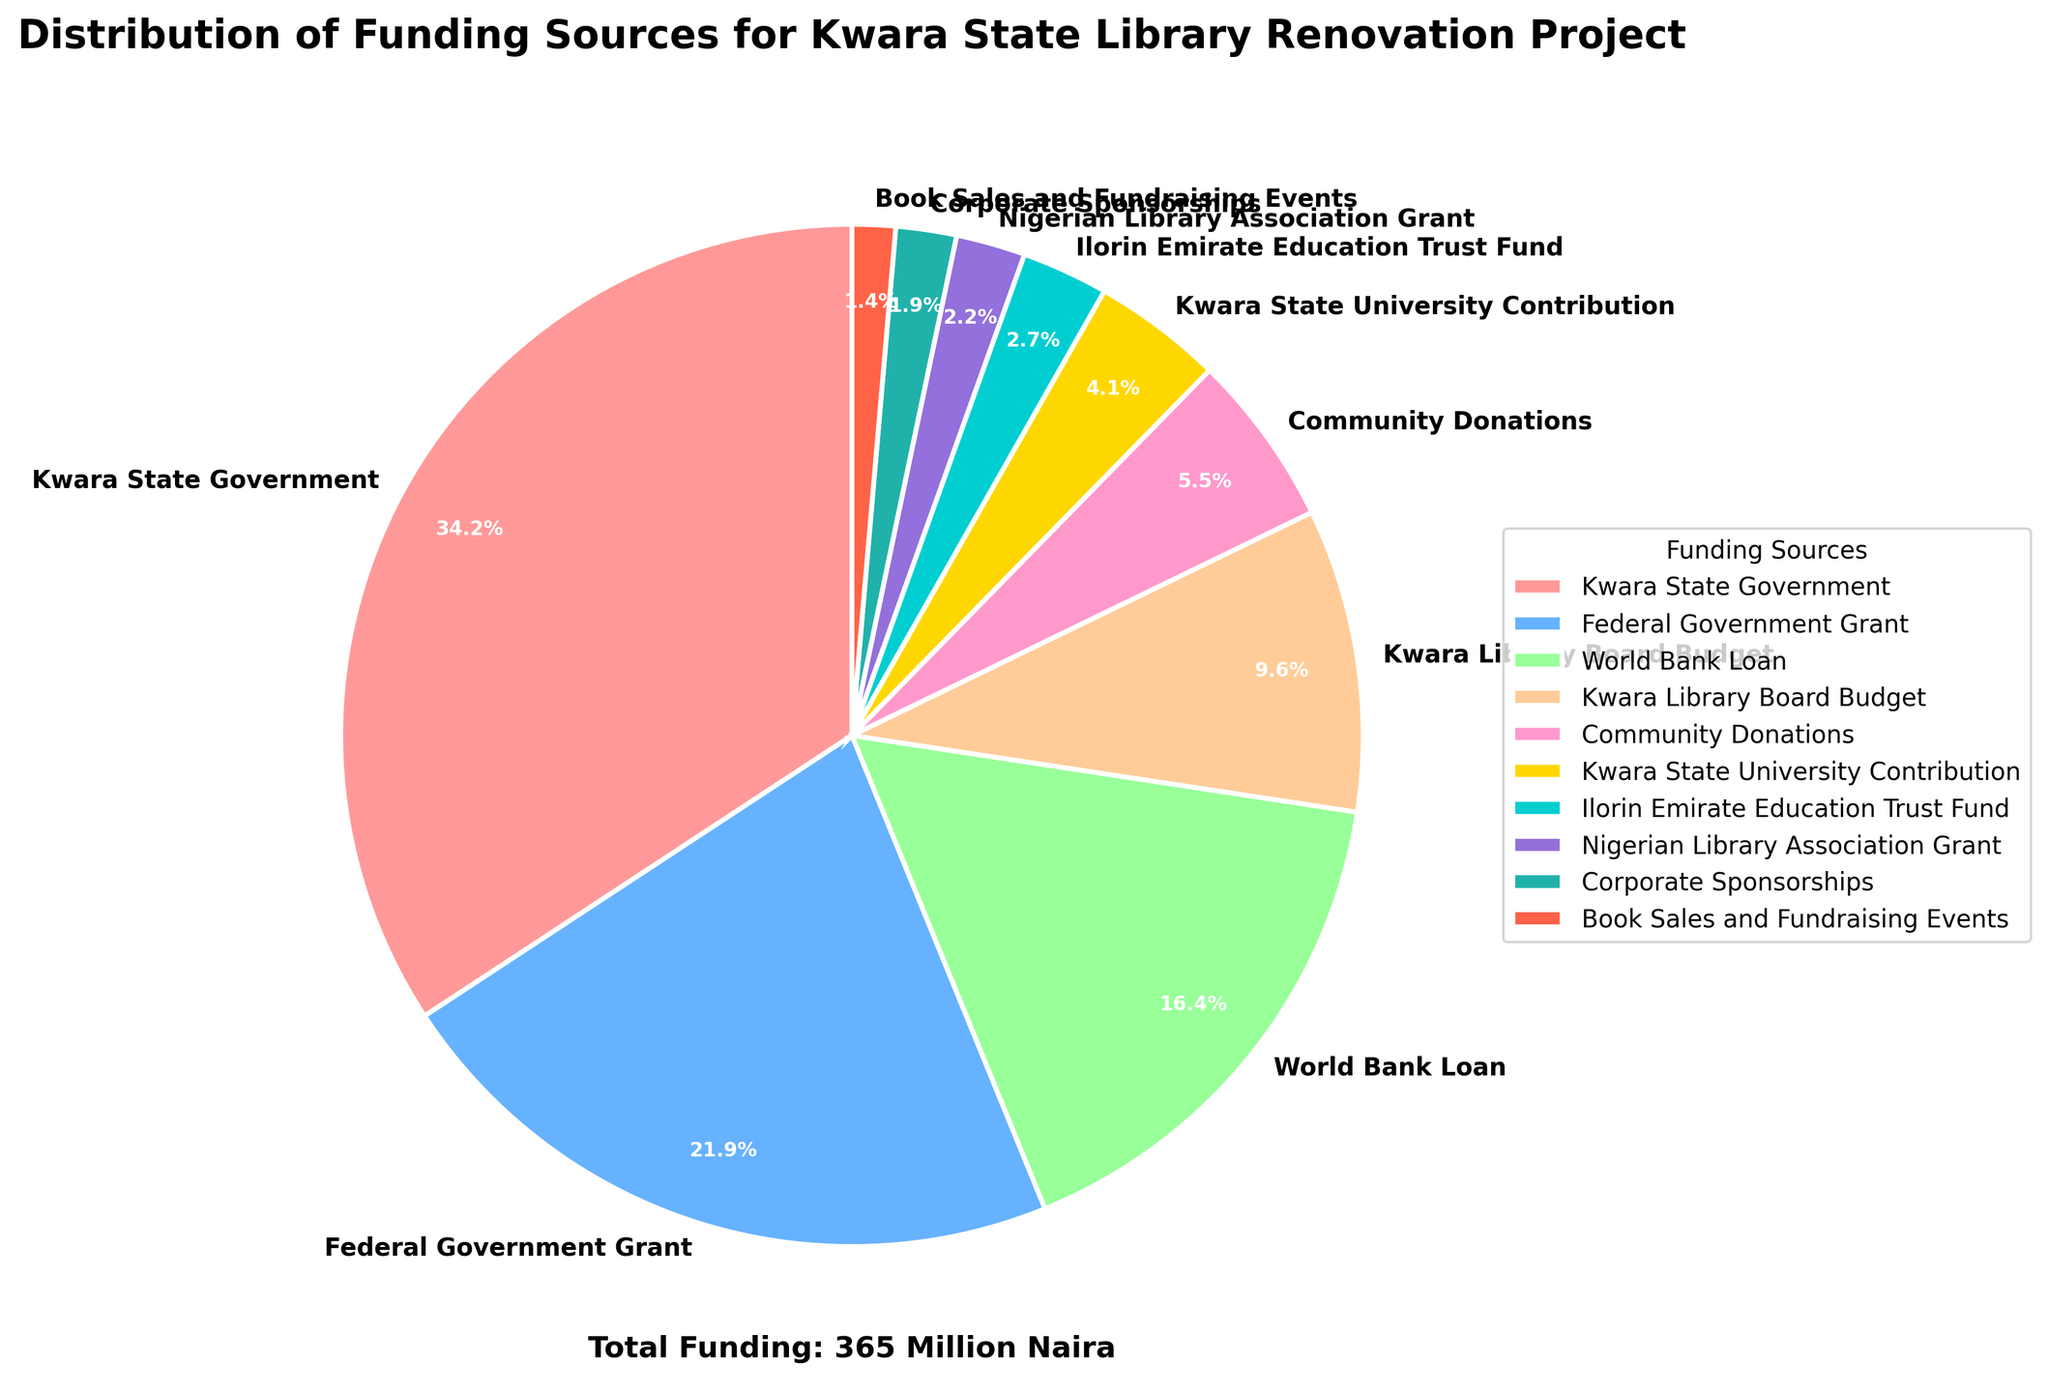What percentage of the funding is contributed by the Federal Government Grant? Looking at the pie chart, the segment labeled "Federal Government Grant" shows a percentage of 21.9%. This represents the portion of the total funding from the Federal Government Grant.
Answer: 21.9% Which two sources have the smallest contributions, and what are their combined percentages? The smallest segments on the pie chart are "Book Sales and Fundraising Events" (1.4%) and "Corporate Sponsorships" (1.9%). Adding these two percentages gives 1.4% + 1.9% = 3.3%.
Answer: 3.3% How much more is the Kwara State Government's contribution compared to Community Donations? The Kwara State Government's contribution is 125 million Naira, and Community Donations are 20 million Naira. The difference is 125 - 20 = 105 million Naira.
Answer: 105 million Naira Which funding source, excluding the top one, contributes the most, and how much is that? By looking at the pie chart, after the Kwara State Government, which is the top contributor, the Federal Government Grant is the next highest at 80 million Naira.
Answer: 80 million Naira What is the total amount contributed by the World Bank Loan and the Kwara Library Board Budget combined? The amounts for the World Bank Loan and Kwara Library Board Budget are 60 million Naira and 35 million Naira, respectively. Summing these gives 60 + 35 = 95 million Naira.
Answer: 95 million Naira Which segment is depicted in light green, and what percentage does it represent? The light green segment in the pie chart corresponds to the "World Bank Loan," which represents 16.4% of the total funding.
Answer: World Bank Loan, 16.4% How many funding sources contribute less than 10 million Naira each, and which are they? From the pie chart, "Ilorin Emirate Education Trust Fund" (10 million Naira), "Nigerian Library Association Grant" (8 million Naira), "Corporate Sponsorships" (7 million Naira), and "Book Sales and Fundraising Events" (5 million Naira) each contribute less than 10 million Naira. Thus, there are 3 sources: "Nigerian Library Association Grant," "Corporate Sponsorships," and "Book Sales and Fundraising Events."
Answer: 3 sources, "Nigerian Library Association Grant," "Corporate Sponsorships," "Book Sales and Fundraising Events" What is the combined percentage of funding from the World Bank Loan and Community Donations? The World Bank Loan is 16.4% and Community Donations is 5.5%. Adding these gives 16.4% + 5.5% = 21.9%.
Answer: 21.9% What is the difference in percentage between the Kwara State Government contribution and the Kwara State University Contribution? The Kwara State Government's contribution percentage is the largest at 34.2%, while the Kwara State University Contribution is 4.1%. The difference is 34.2% - 4.1% = 30.1%.
Answer: 30.1% 